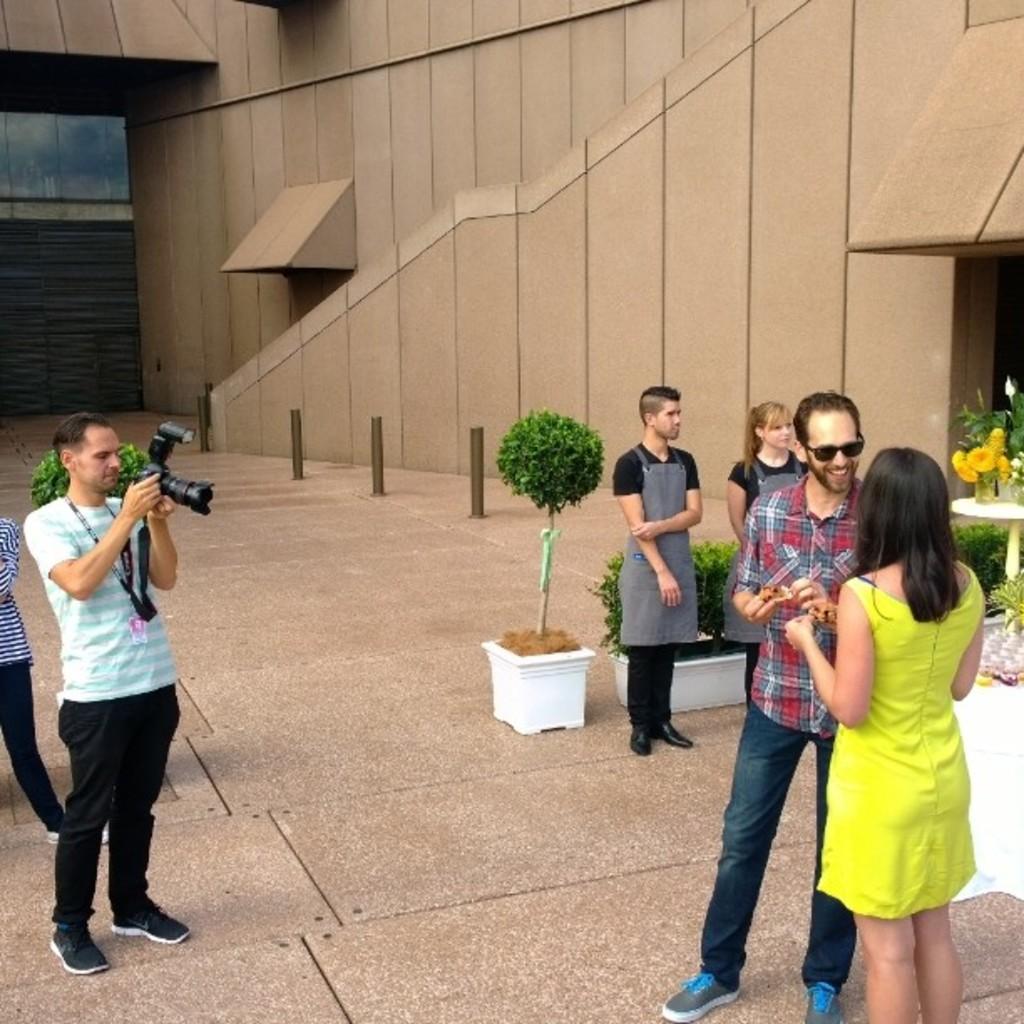Describe this image in one or two sentences. In this image we can see persons standing on the floor and one of them is holding a camera in the hands, houseplants, walls and barrier poles. 